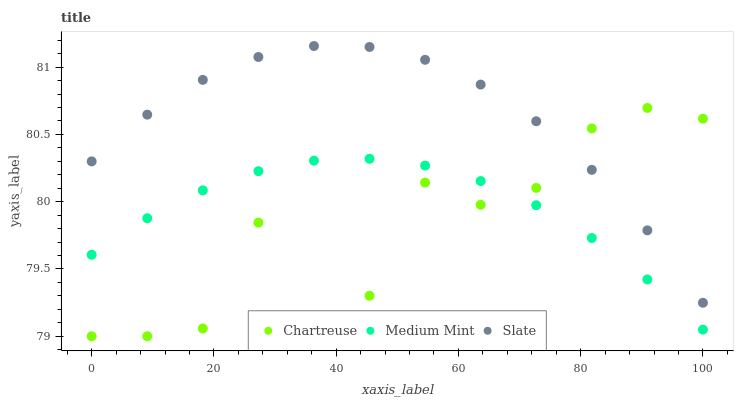Does Chartreuse have the minimum area under the curve?
Answer yes or no. Yes. Does Slate have the maximum area under the curve?
Answer yes or no. Yes. Does Slate have the minimum area under the curve?
Answer yes or no. No. Does Chartreuse have the maximum area under the curve?
Answer yes or no. No. Is Medium Mint the smoothest?
Answer yes or no. Yes. Is Chartreuse the roughest?
Answer yes or no. Yes. Is Slate the smoothest?
Answer yes or no. No. Is Slate the roughest?
Answer yes or no. No. Does Chartreuse have the lowest value?
Answer yes or no. Yes. Does Slate have the lowest value?
Answer yes or no. No. Does Slate have the highest value?
Answer yes or no. Yes. Does Chartreuse have the highest value?
Answer yes or no. No. Is Medium Mint less than Slate?
Answer yes or no. Yes. Is Slate greater than Medium Mint?
Answer yes or no. Yes. Does Chartreuse intersect Slate?
Answer yes or no. Yes. Is Chartreuse less than Slate?
Answer yes or no. No. Is Chartreuse greater than Slate?
Answer yes or no. No. Does Medium Mint intersect Slate?
Answer yes or no. No. 